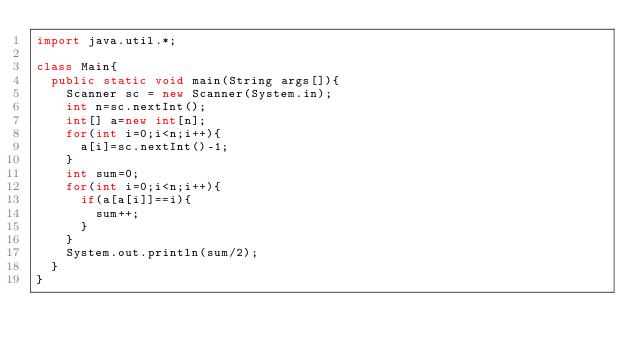Convert code to text. <code><loc_0><loc_0><loc_500><loc_500><_Java_>import java.util.*;

class Main{
  public static void main(String args[]){
    Scanner sc = new Scanner(System.in);
    int n=sc.nextInt();
    int[] a=new int[n];
    for(int i=0;i<n;i++){
      a[i]=sc.nextInt()-1;
    }
    int sum=0;
    for(int i=0;i<n;i++){
      if(a[a[i]]==i){
        sum++;
      }
    }
    System.out.println(sum/2);
  }
}</code> 